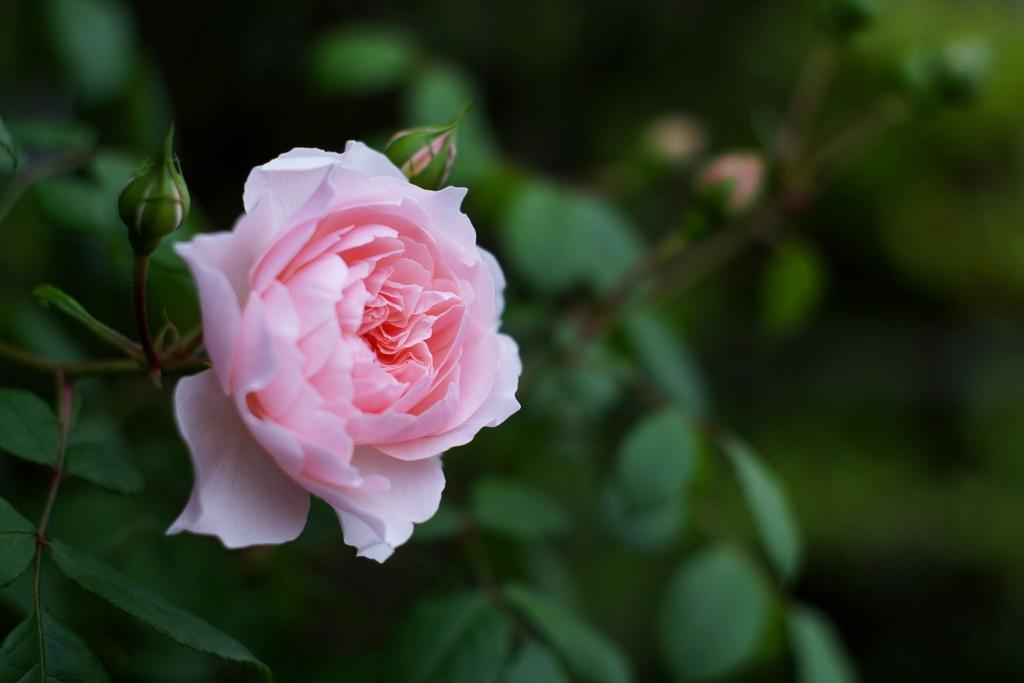Can you describe this image briefly? On the left side of this image I can see a plant along with the flower and few buds. The background is blurred. 